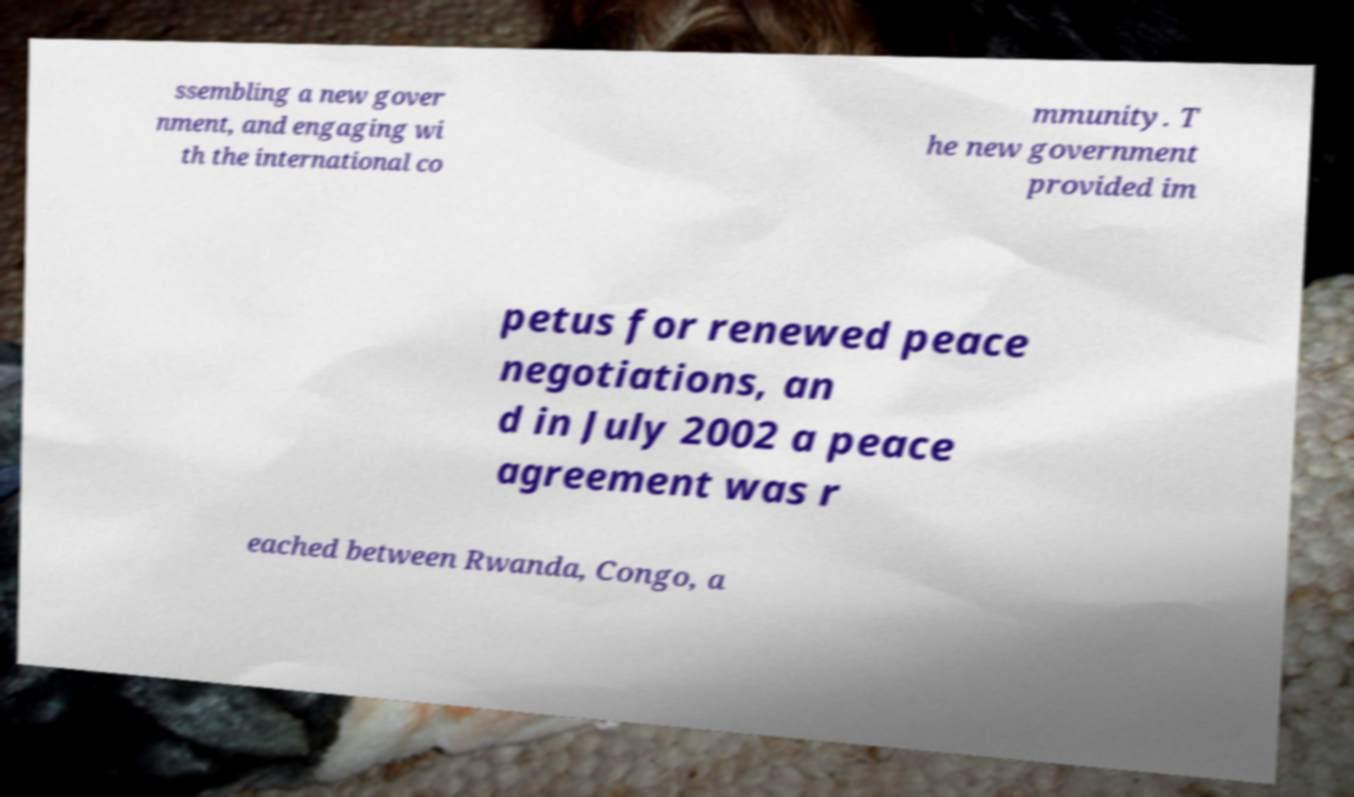Can you accurately transcribe the text from the provided image for me? ssembling a new gover nment, and engaging wi th the international co mmunity. T he new government provided im petus for renewed peace negotiations, an d in July 2002 a peace agreement was r eached between Rwanda, Congo, a 